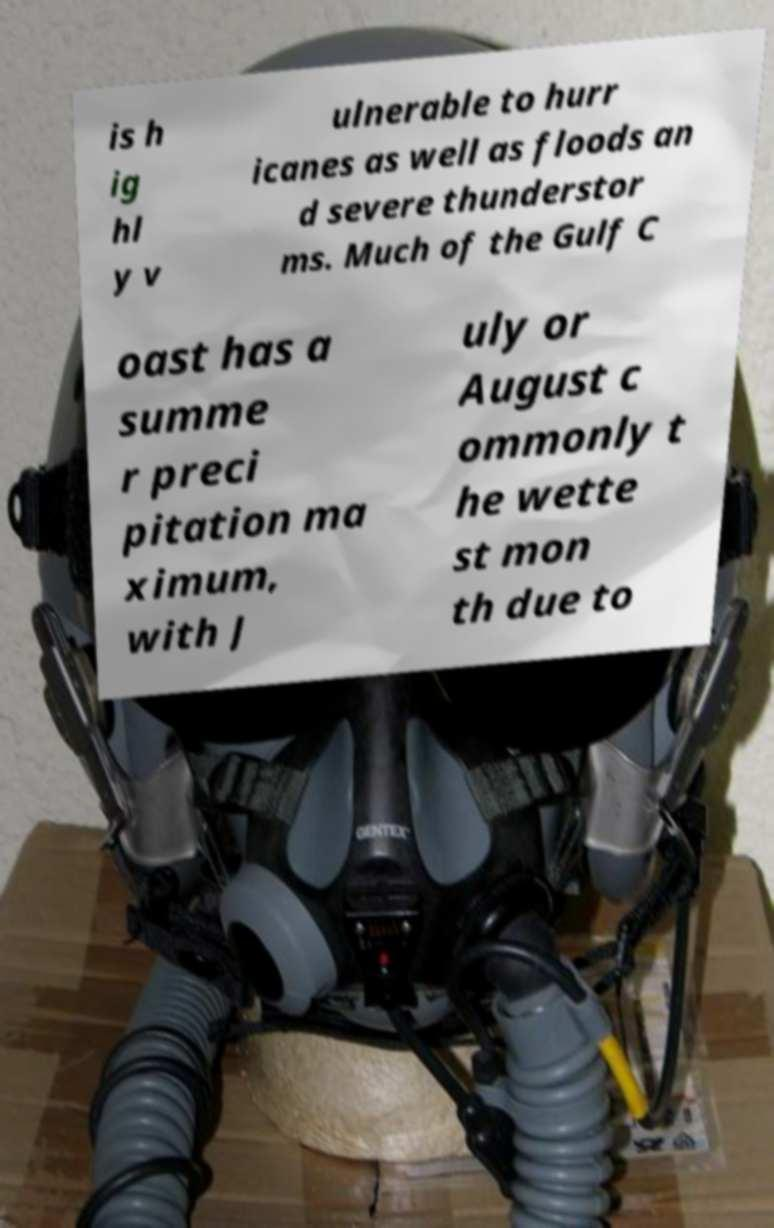Please identify and transcribe the text found in this image. is h ig hl y v ulnerable to hurr icanes as well as floods an d severe thunderstor ms. Much of the Gulf C oast has a summe r preci pitation ma ximum, with J uly or August c ommonly t he wette st mon th due to 